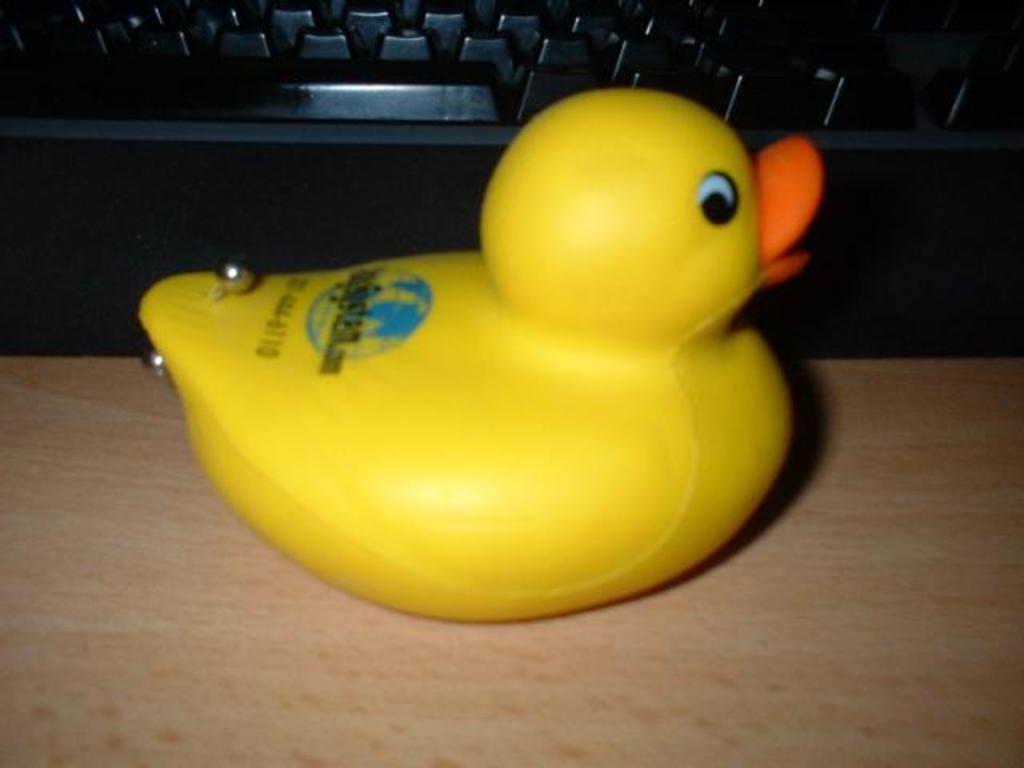What type of toy is on the wooden table in the image? There is a yellow duck toy on the wooden table. What other object can be seen on the table? There is a black computer keyboard on the surface. What type of liquid is being poured on the yellow duck toy in the image? There is no liquid being poured on the yellow duck toy in the image. How many cattle are present in the image? There are no cattle present in the image. 